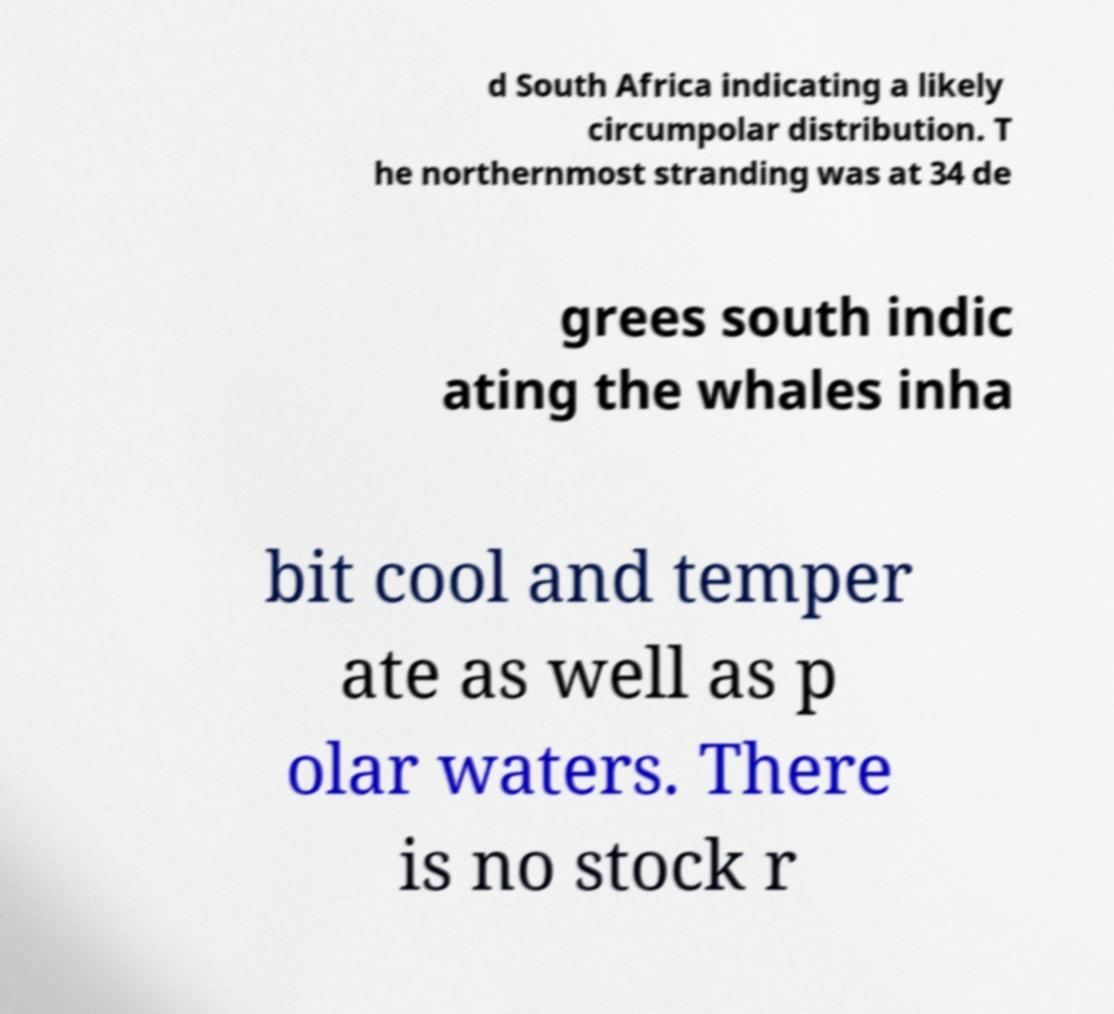Could you extract and type out the text from this image? d South Africa indicating a likely circumpolar distribution. T he northernmost stranding was at 34 de grees south indic ating the whales inha bit cool and temper ate as well as p olar waters. There is no stock r 